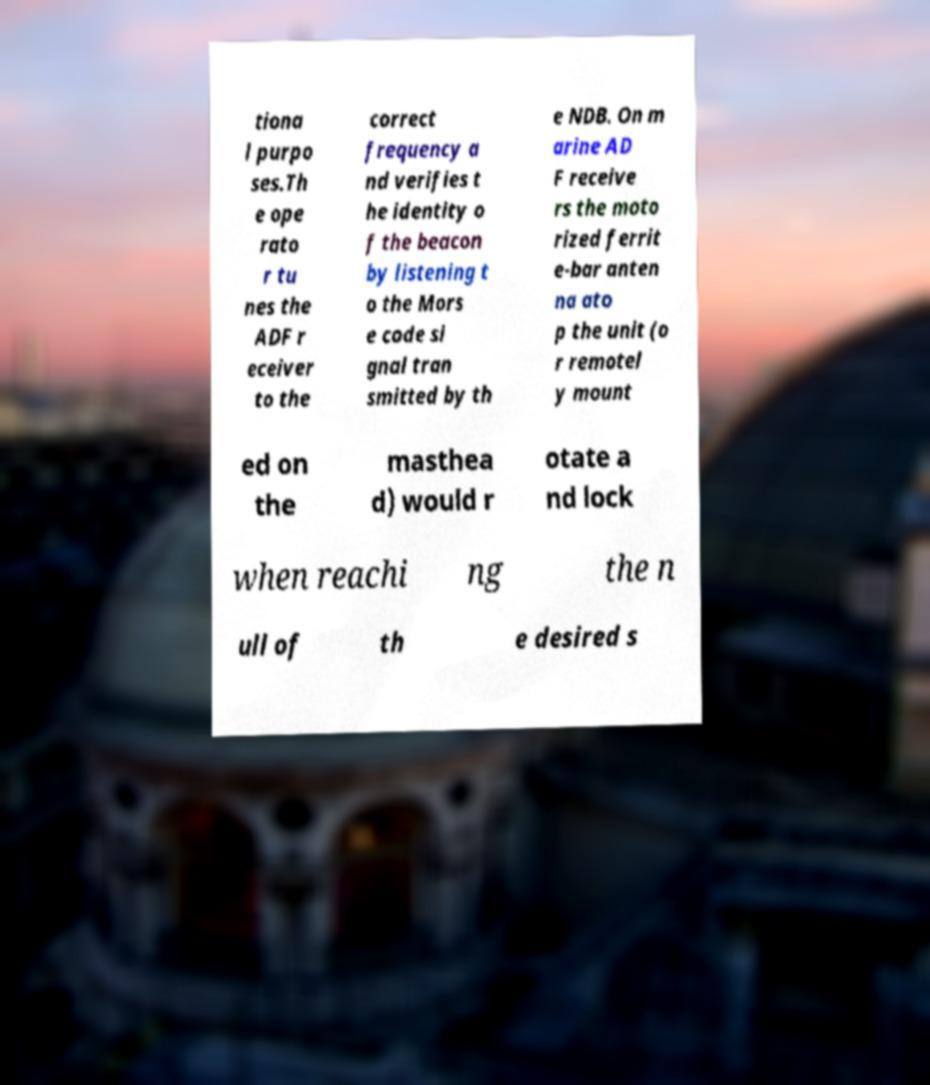Please read and relay the text visible in this image. What does it say? tiona l purpo ses.Th e ope rato r tu nes the ADF r eceiver to the correct frequency a nd verifies t he identity o f the beacon by listening t o the Mors e code si gnal tran smitted by th e NDB. On m arine AD F receive rs the moto rized ferrit e-bar anten na ato p the unit (o r remotel y mount ed on the masthea d) would r otate a nd lock when reachi ng the n ull of th e desired s 